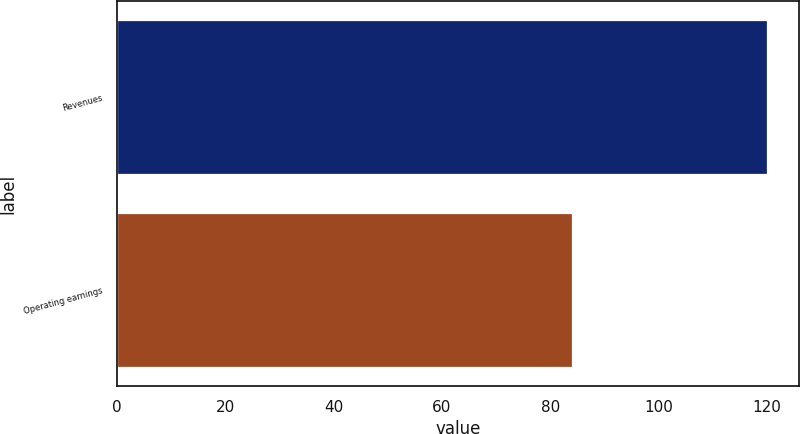<chart> <loc_0><loc_0><loc_500><loc_500><bar_chart><fcel>Revenues<fcel>Operating earnings<nl><fcel>120<fcel>84<nl></chart> 